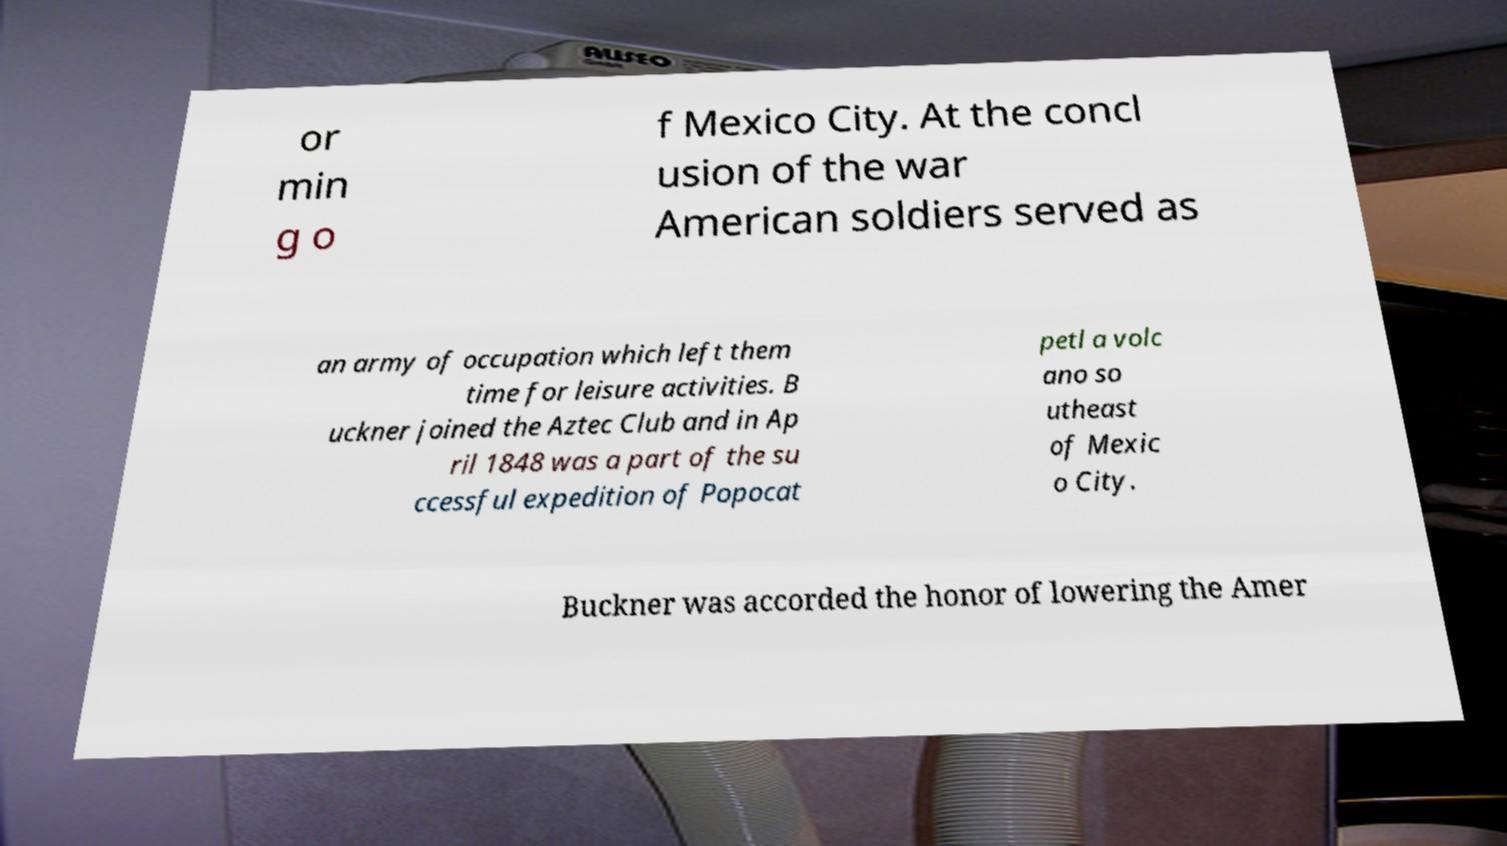I need the written content from this picture converted into text. Can you do that? or min g o f Mexico City. At the concl usion of the war American soldiers served as an army of occupation which left them time for leisure activities. B uckner joined the Aztec Club and in Ap ril 1848 was a part of the su ccessful expedition of Popocat petl a volc ano so utheast of Mexic o City. Buckner was accorded the honor of lowering the Amer 